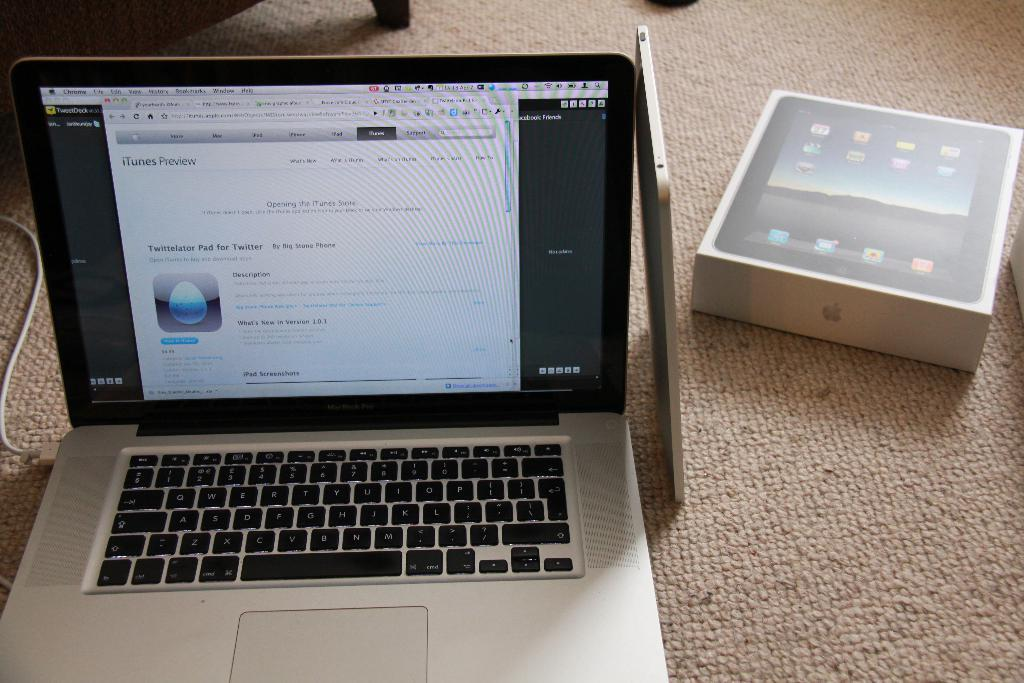<image>
Present a compact description of the photo's key features. A mac laptop opened to an itunes help page. 